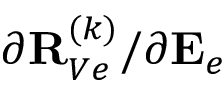<formula> <loc_0><loc_0><loc_500><loc_500>{ \partial { R } _ { V e } ^ { ( k ) } } / { \partial { E } _ { e } }</formula> 